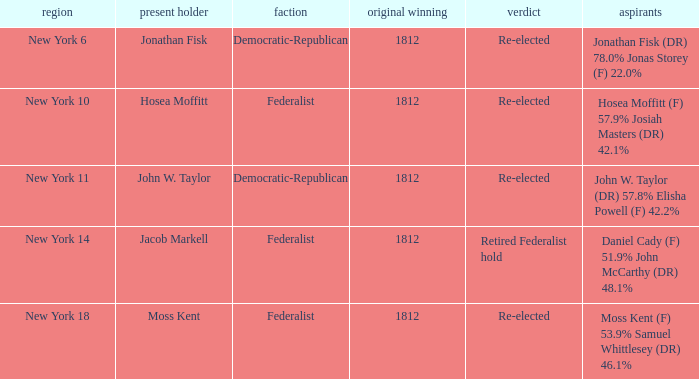Can you parse all the data within this table? {'header': ['region', 'present holder', 'faction', 'original winning', 'verdict', 'aspirants'], 'rows': [['New York 6', 'Jonathan Fisk', 'Democratic-Republican', '1812', 'Re-elected', 'Jonathan Fisk (DR) 78.0% Jonas Storey (F) 22.0%'], ['New York 10', 'Hosea Moffitt', 'Federalist', '1812', 'Re-elected', 'Hosea Moffitt (F) 57.9% Josiah Masters (DR) 42.1%'], ['New York 11', 'John W. Taylor', 'Democratic-Republican', '1812', 'Re-elected', 'John W. Taylor (DR) 57.8% Elisha Powell (F) 42.2%'], ['New York 14', 'Jacob Markell', 'Federalist', '1812', 'Retired Federalist hold', 'Daniel Cady (F) 51.9% John McCarthy (DR) 48.1%'], ['New York 18', 'Moss Kent', 'Federalist', '1812', 'Re-elected', 'Moss Kent (F) 53.9% Samuel Whittlesey (DR) 46.1%']]} Name the most first elected 1812.0. 